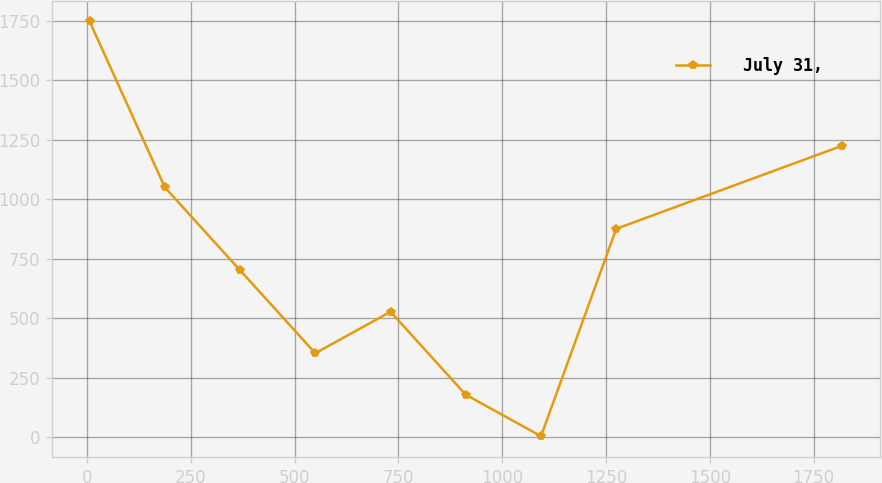Convert chart. <chart><loc_0><loc_0><loc_500><loc_500><line_chart><ecel><fcel>July 31,<nl><fcel>5.98<fcel>1748.18<nl><fcel>187.2<fcel>1050.67<nl><fcel>368.42<fcel>701.93<nl><fcel>549.64<fcel>353.19<nl><fcel>730.86<fcel>527.56<nl><fcel>912.08<fcel>178.82<nl><fcel>1093.3<fcel>4.45<nl><fcel>1274.52<fcel>876.3<nl><fcel>1818.16<fcel>1225.04<nl></chart> 